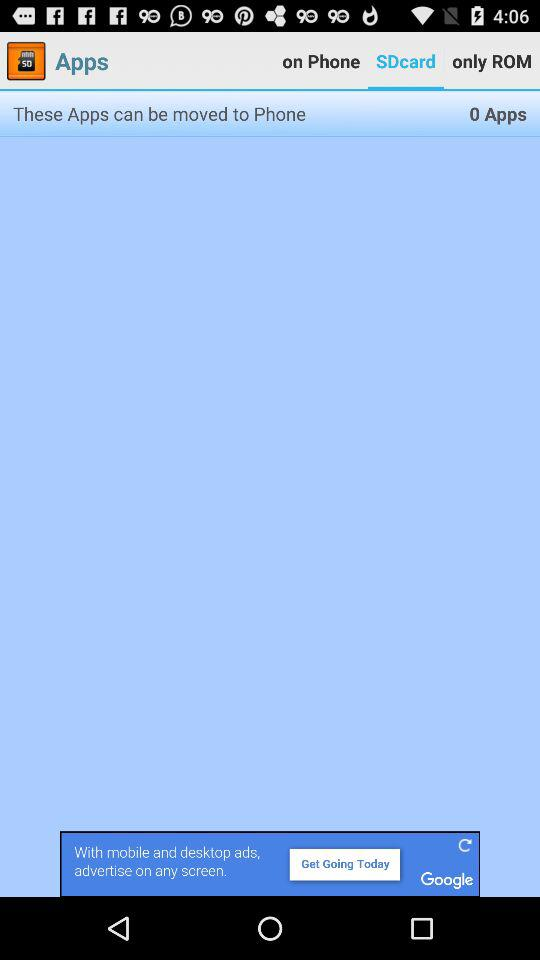How many apps can be moved to the phone? The apps that can be moved to the phone are 0. 